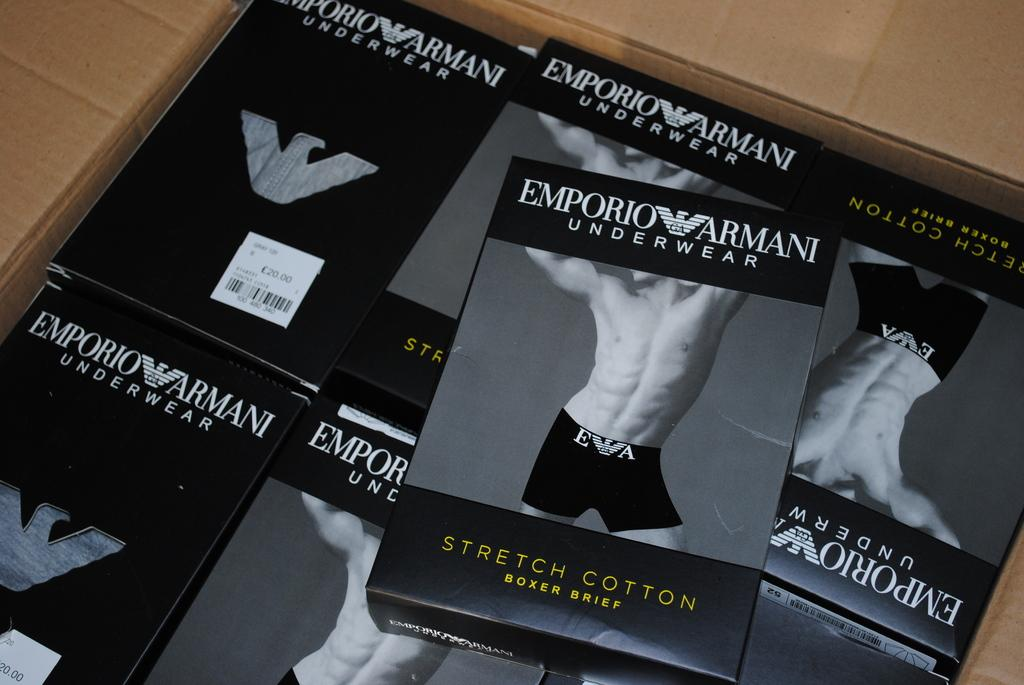Provide a one-sentence caption for the provided image. A collection of Emporio Armani underwear in a brown box. 